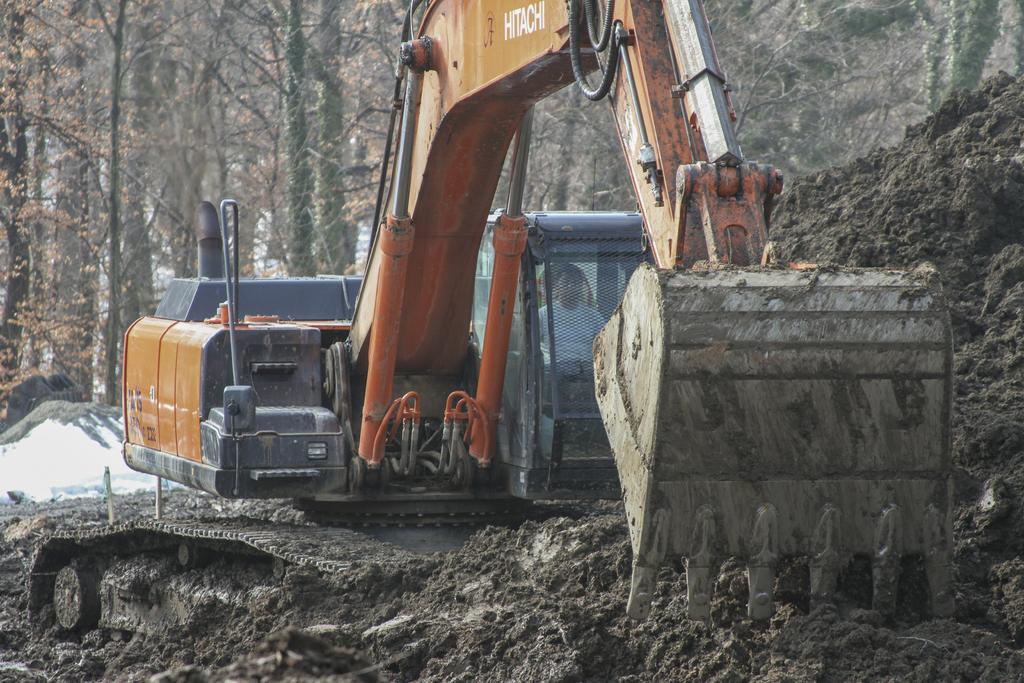What is the main subject of the picture? The main subject of the picture is a bulldozer. Is there anyone operating the bulldozer? Yes, there is a person riding the bulldozer. What type of terrain is visible in the picture? Soil is visible in the picture. What can be seen in the background of the picture? There are trees in the background of the picture. What type of pollution can be seen coming from the bulldozer in the image? There is no indication of pollution in the image; it only shows a bulldozer and a person riding it. 